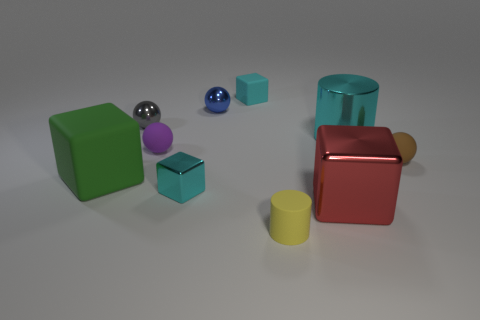Is there any other thing that is the same shape as the tiny cyan matte thing?
Your response must be concise. Yes. There is a large object behind the purple ball; is it the same shape as the tiny matte thing that is in front of the large green matte cube?
Your answer should be very brief. Yes. There is a green rubber cube; does it have the same size as the matte block behind the green matte block?
Offer a very short reply. No. Are there more large metal cubes than matte blocks?
Provide a short and direct response. No. Is the material of the cylinder that is in front of the big shiny block the same as the small sphere that is on the right side of the red block?
Provide a short and direct response. Yes. What is the big green block made of?
Offer a terse response. Rubber. Is the number of small blue things that are on the left side of the tiny rubber cylinder greater than the number of small gray rubber cylinders?
Your answer should be very brief. Yes. What number of small cyan things are to the left of the small metallic sphere to the right of the small cube in front of the green matte thing?
Offer a terse response. 1. There is a small ball that is both in front of the cyan cylinder and to the left of the tiny cylinder; what is its material?
Your answer should be very brief. Rubber. The large cylinder is what color?
Give a very brief answer. Cyan. 